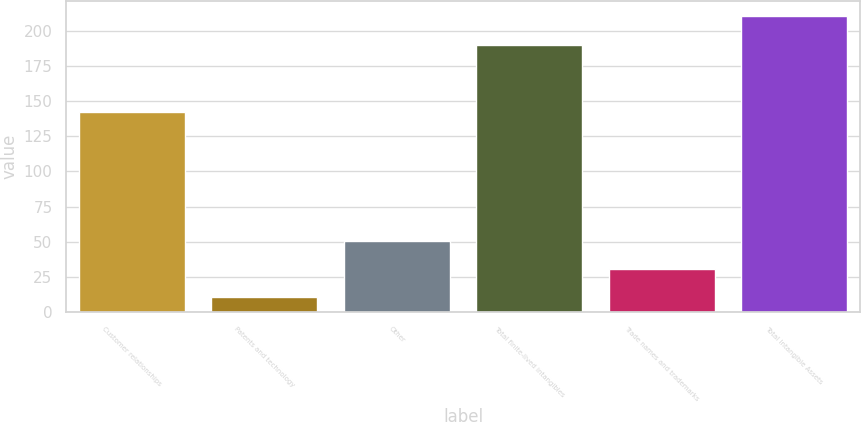Convert chart. <chart><loc_0><loc_0><loc_500><loc_500><bar_chart><fcel>Customer relationships<fcel>Patents and technology<fcel>Other<fcel>Total finite-lived intangibles<fcel>Trade names and trademarks<fcel>Total Intangible Assets<nl><fcel>142.3<fcel>10.6<fcel>50.56<fcel>189.5<fcel>30.58<fcel>210.4<nl></chart> 